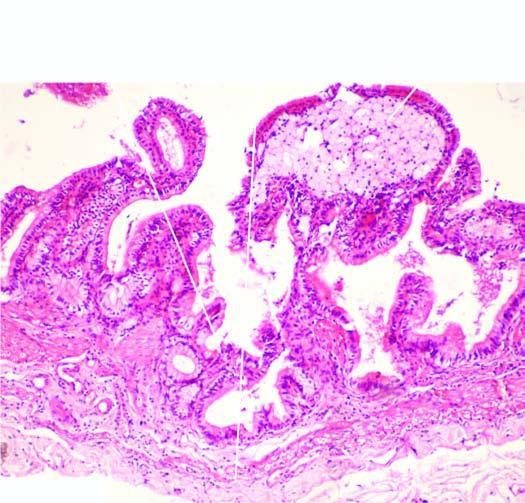what shows foamy macrophages?
Answer the question using a single word or phrase. Lamina propria of the mucosa 